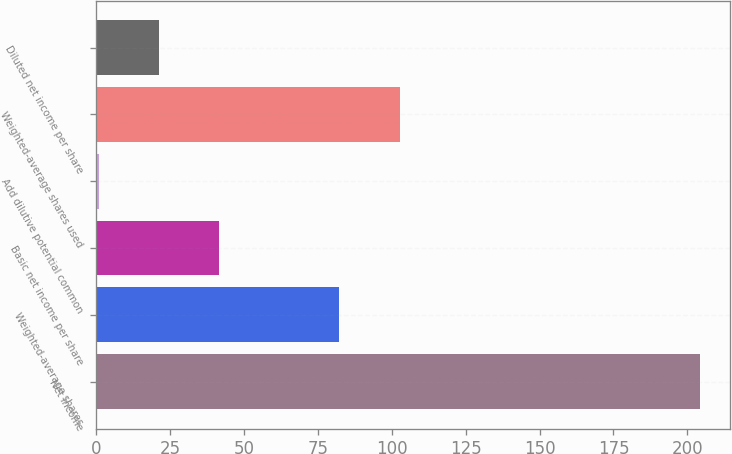<chart> <loc_0><loc_0><loc_500><loc_500><bar_chart><fcel>Net income<fcel>Weighted-average shares<fcel>Basic net income per share<fcel>Add dilutive potential common<fcel>Weighted-average shares used<fcel>Diluted net income per share<nl><fcel>204.3<fcel>82.32<fcel>41.66<fcel>1<fcel>102.65<fcel>21.33<nl></chart> 